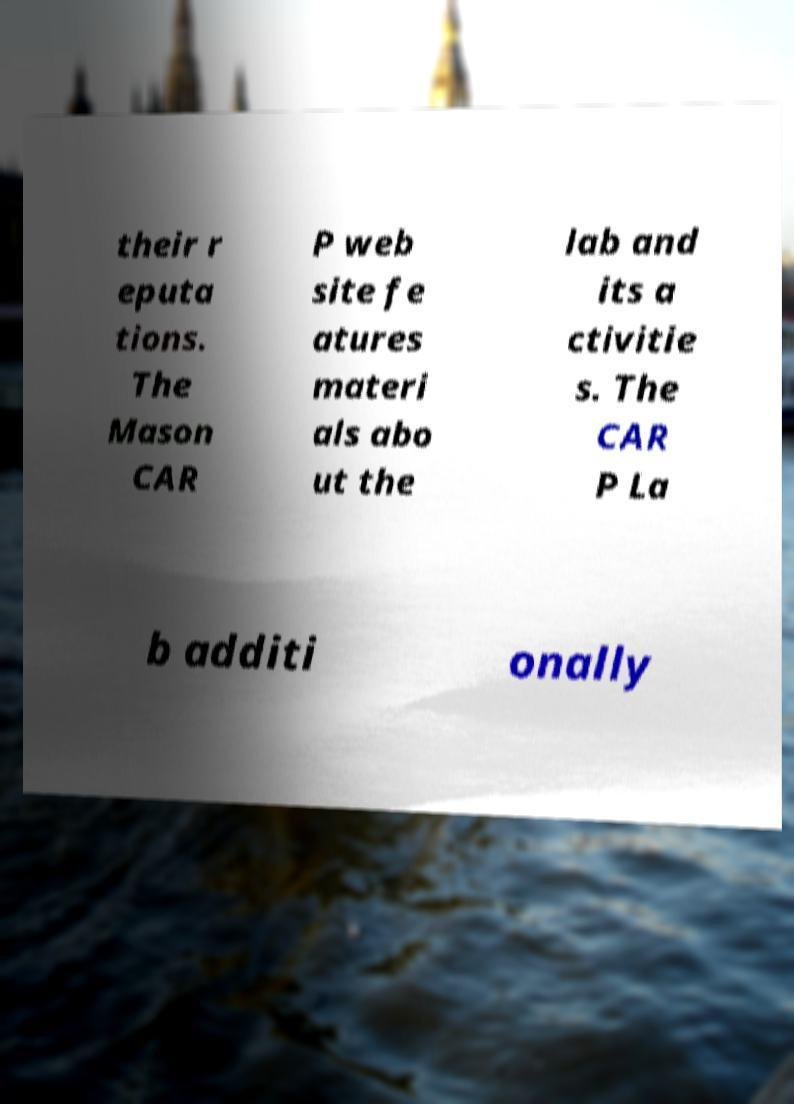For documentation purposes, I need the text within this image transcribed. Could you provide that? their r eputa tions. The Mason CAR P web site fe atures materi als abo ut the lab and its a ctivitie s. The CAR P La b additi onally 